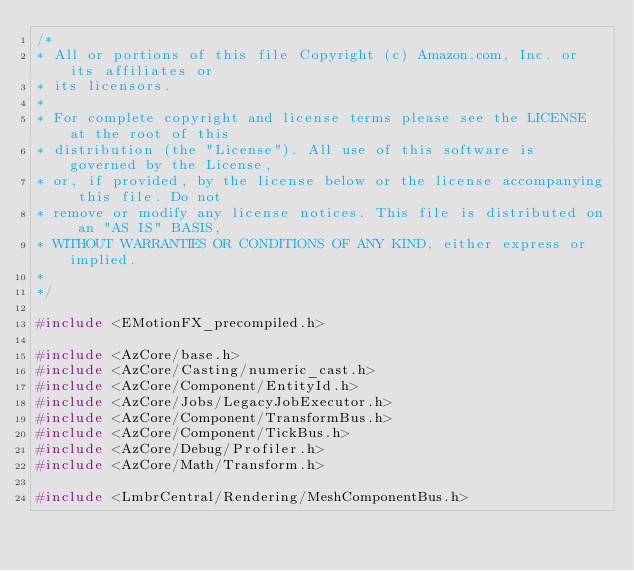Convert code to text. <code><loc_0><loc_0><loc_500><loc_500><_C++_>/*
* All or portions of this file Copyright (c) Amazon.com, Inc. or its affiliates or
* its licensors.
*
* For complete copyright and license terms please see the LICENSE at the root of this
* distribution (the "License"). All use of this software is governed by the License,
* or, if provided, by the license below or the license accompanying this file. Do not
* remove or modify any license notices. This file is distributed on an "AS IS" BASIS,
* WITHOUT WARRANTIES OR CONDITIONS OF ANY KIND, either express or implied.
*
*/

#include <EMotionFX_precompiled.h>

#include <AzCore/base.h>
#include <AzCore/Casting/numeric_cast.h>
#include <AzCore/Component/EntityId.h>
#include <AzCore/Jobs/LegacyJobExecutor.h>
#include <AzCore/Component/TransformBus.h>
#include <AzCore/Component/TickBus.h>
#include <AzCore/Debug/Profiler.h>
#include <AzCore/Math/Transform.h>

#include <LmbrCentral/Rendering/MeshComponentBus.h>
</code> 